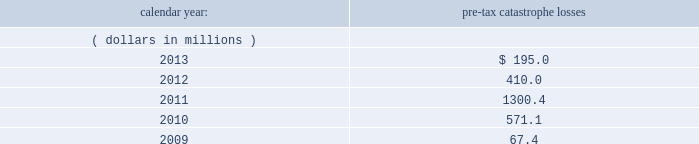Corporate income taxes other than withholding taxes on certain investment income and premium excise taxes .
If group or its bermuda subsidiaries were to become subject to u.s .
Income tax , there could be a material adverse effect on the company 2019s financial condition , results of operations and cash flows .
United kingdom .
Bermuda re 2019s uk branch conducts business in the uk and is subject to taxation in the uk .
Bermuda re believes that it has operated and will continue to operate its bermuda operation in a manner which will not cause them to be subject to uk taxation .
If bermuda re 2019s bermuda operations were to become subject to uk income tax , there could be a material adverse impact on the company 2019s financial condition , results of operations and cash flow .
Ireland .
Holdings ireland and ireland re conduct business in ireland and are subject to taxation in ireland .
Available information .
The company 2019s annual reports on form 10-k , quarterly reports on form 10-q , current reports on form 8- k , proxy statements and amendments to those reports are available free of charge through the company 2019s internet website at http://www.everestregroup.com as soon as reasonably practicable after such reports are electronically filed with the securities and exchange commission ( the 201csec 201d ) .
Item 1a .
Risk factors in addition to the other information provided in this report , the following risk factors should be considered when evaluating an investment in our securities .
If the circumstances contemplated by the individual risk factors materialize , our business , financial condition and results of operations could be materially and adversely affected and the trading price of our common shares could decline significantly .
Risks relating to our business fluctuations in the financial markets could result in investment losses .
Prolonged and severe disruptions in the public debt and equity markets , such as occurred during 2008 , could result in significant realized and unrealized losses in our investment portfolio .
Although financial markets have significantly improved since 2008 , they could deteriorate in the future .
Such declines in the financial markets could result in significant realized and unrealized losses on investments and could have a material adverse impact on our results of operations , equity , business and insurer financial strength and debt ratings .
Our results could be adversely affected by catastrophic events .
We are exposed to unpredictable catastrophic events , including weather-related and other natural catastrophes , as well as acts of terrorism .
Any material reduction in our operating results caused by the occurrence of one or more catastrophes could inhibit our ability to pay dividends or to meet our interest and principal payment obligations .
Subsequent to april 1 , 2010 , we define a catastrophe as an event that causes a loss on property exposures before reinsurance of at least $ 10.0 million , before corporate level reinsurance and taxes .
Prior to april 1 , 2010 , we used a threshold of $ 5.0 million .
By way of illustration , during the past five calendar years , pre-tax catastrophe losses , net of contract specific reinsurance but before cessions under corporate reinsurance programs , were as follows: .

What was the amount of change in pre-tax catastrophe losses from 2010 to 2011 in millions? 
Computations: (1300.4 - 571.1)
Answer: 729.3. 